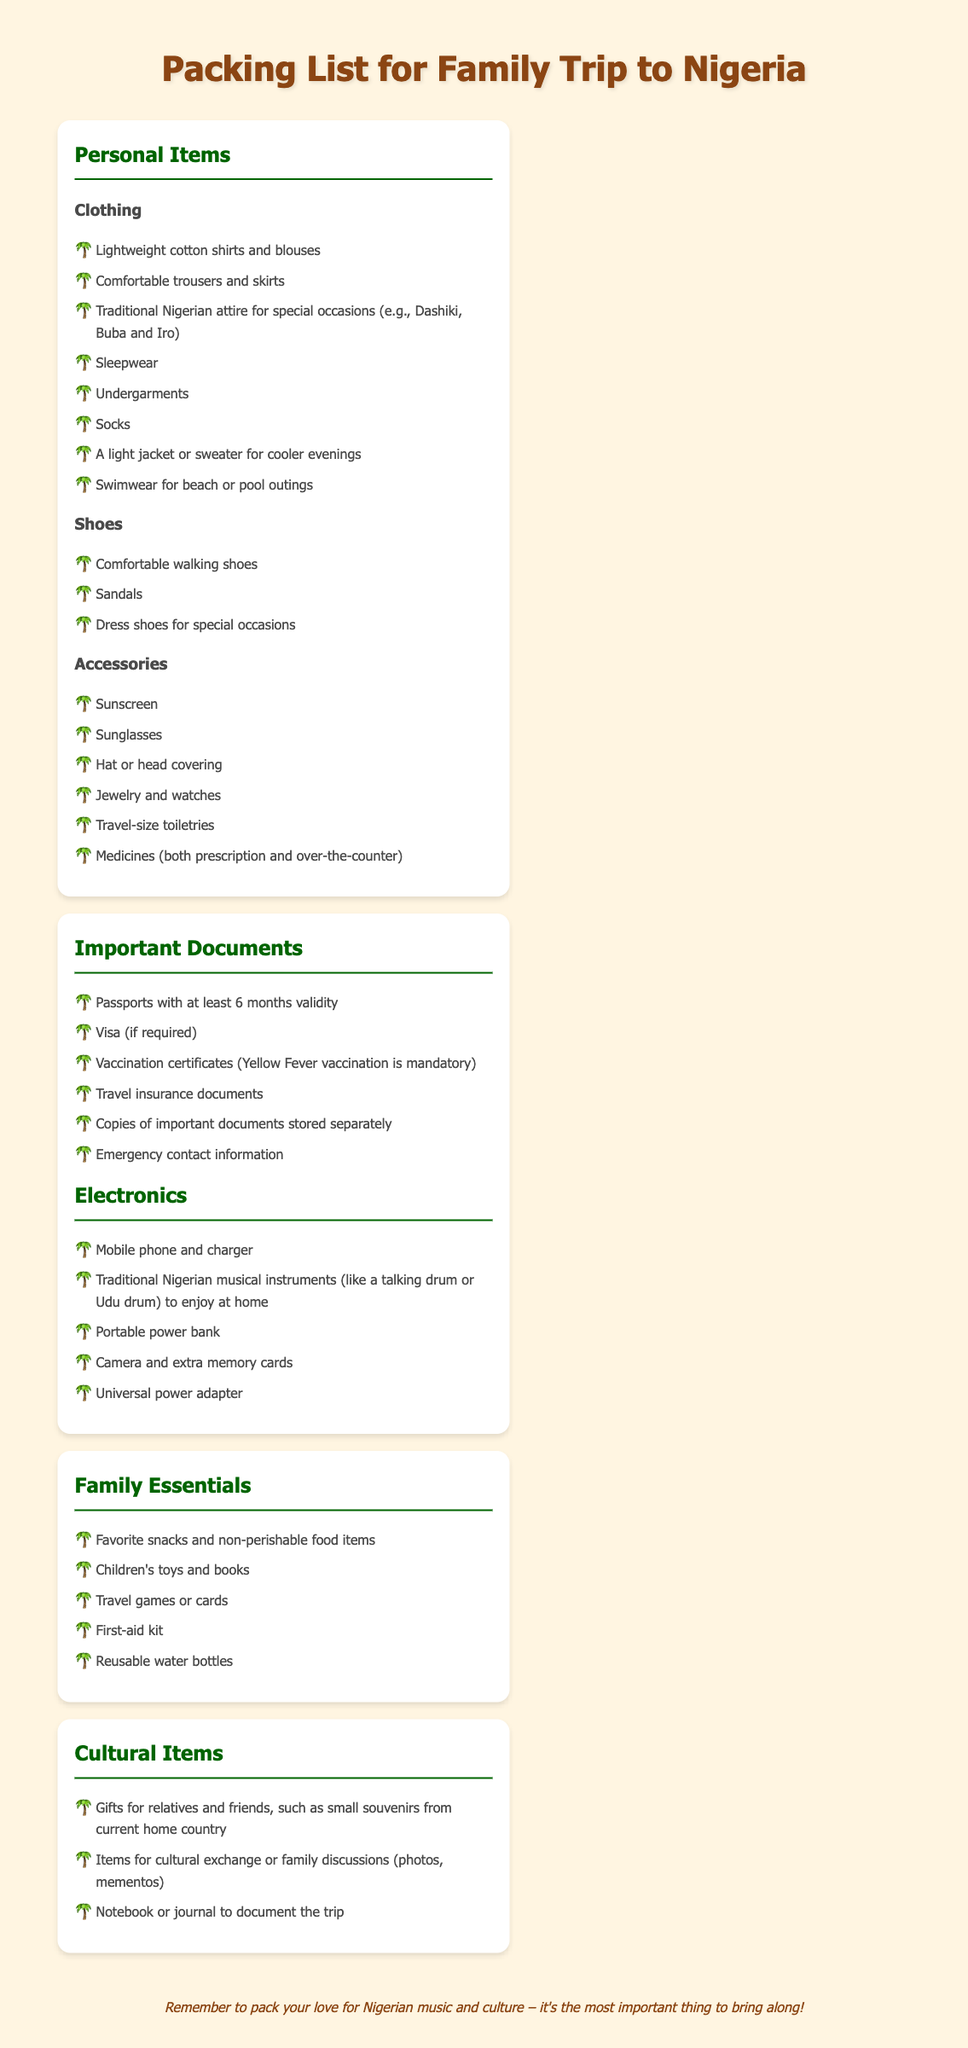What types of clothing should be packed? The clothing section lists several types recommended for the trip, including lightweight cotton shirts and traditional Nigerian attire.
Answer: Lightweight cotton shirts and traditional Nigerian attire How many types of shoes are mentioned? The shoes section lists three different types of footwear suggested for packing.
Answer: Three What is mandatory to have in vaccination certificates? The document specifies a required vaccination that must be reflected on the certificates for travel.
Answer: Yellow Fever vaccination Which electronics are suggested to bring? The electronics section includes various devices, highlighting the importance of musical instruments.
Answer: Traditional Nigerian musical instruments What should be included in the family essentials? The section discusses various items that are crucial for family comfort during travel.
Answer: Favorite snacks and non-perishable food items What cultural item is recommended for family discussions? The cultural items section advises including materials that foster dialogue about heritage and exchange among family.
Answer: Items for cultural exchange or family discussions How should important documents be stored? The document suggests a security measure for keeping important papers safe for reference during travel.
Answer: Copies of important documents stored separately What should be remembered to pack as the most important thing? The packing list concludes with a note emphasizing the value of cultural and emotional connection.
Answer: Love for Nigerian music and culture 